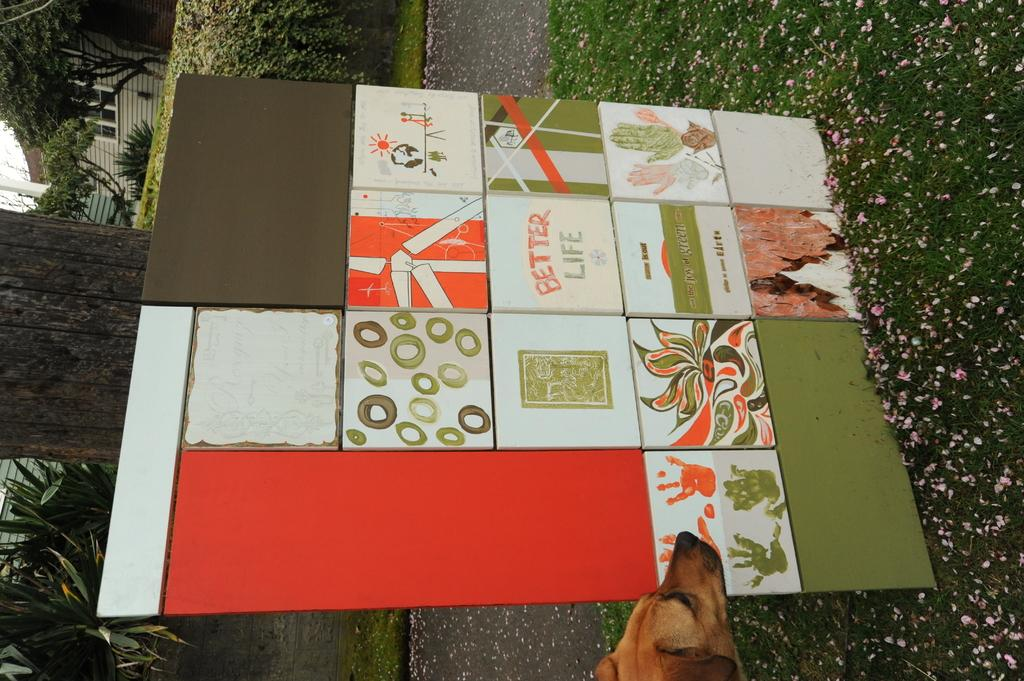What type of animal can be seen in the image? There is a dog in the image. What object is present in the image besides the dog? There is a board in the image. What can be seen in the background of the image? Trees, plants, buildings, and a hedge can be seen in the background of the image. What is visible at the bottom of the image? The ground and a road are visible at the bottom of the image. What type of stage can be seen in the image? There is no stage present in the image. What type of bulb is used to light up the area in the image? There is no mention of any bulbs or lighting in the image. 